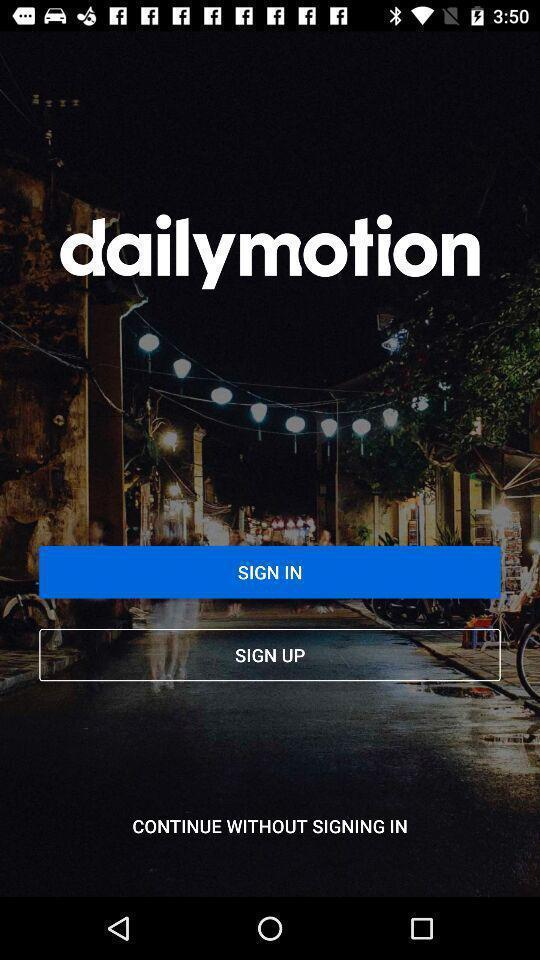Please provide a description for this image. Welcome page of a news app. 